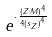<formula> <loc_0><loc_0><loc_500><loc_500>e ^ { \cdot \frac { ( Z \cdot M ) ^ { 4 } } { 4 { ( s _ { Z } ) } ^ { 4 } } }</formula> 